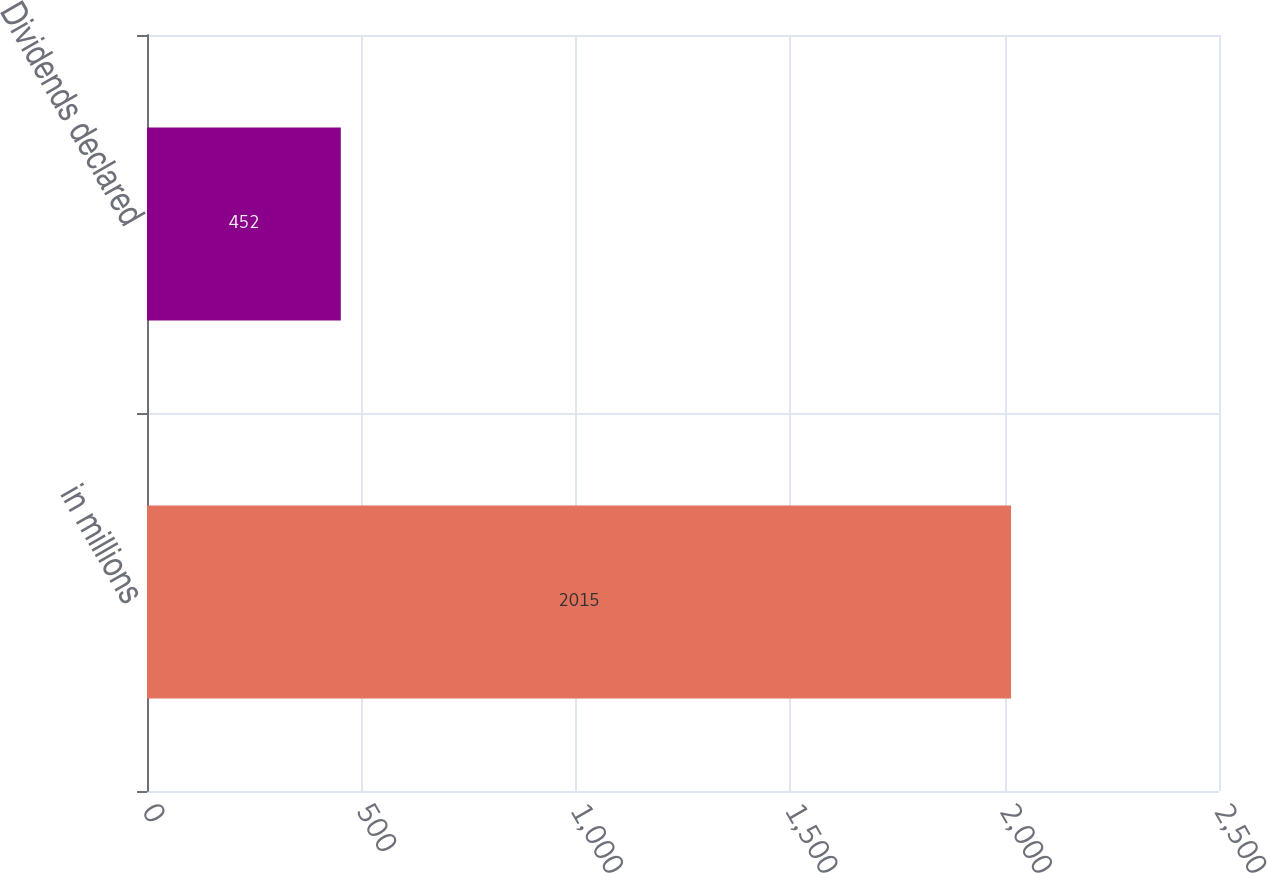Convert chart to OTSL. <chart><loc_0><loc_0><loc_500><loc_500><bar_chart><fcel>in millions<fcel>Dividends declared<nl><fcel>2015<fcel>452<nl></chart> 